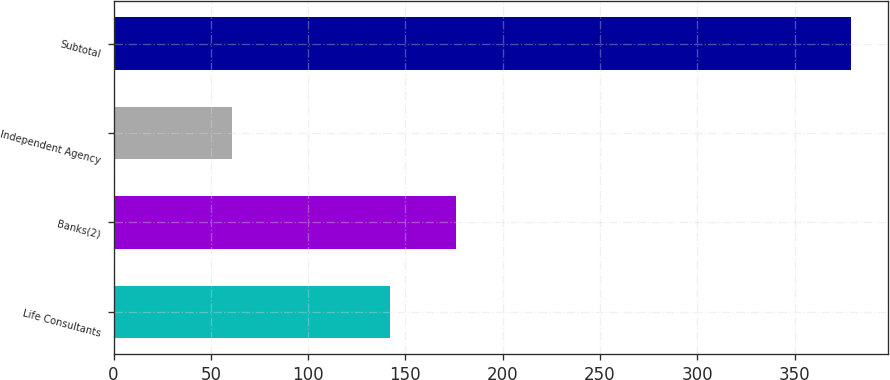Convert chart to OTSL. <chart><loc_0><loc_0><loc_500><loc_500><bar_chart><fcel>Life Consultants<fcel>Banks(2)<fcel>Independent Agency<fcel>Subtotal<nl><fcel>142<fcel>176<fcel>61<fcel>379<nl></chart> 